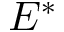Convert formula to latex. <formula><loc_0><loc_0><loc_500><loc_500>E ^ { * }</formula> 